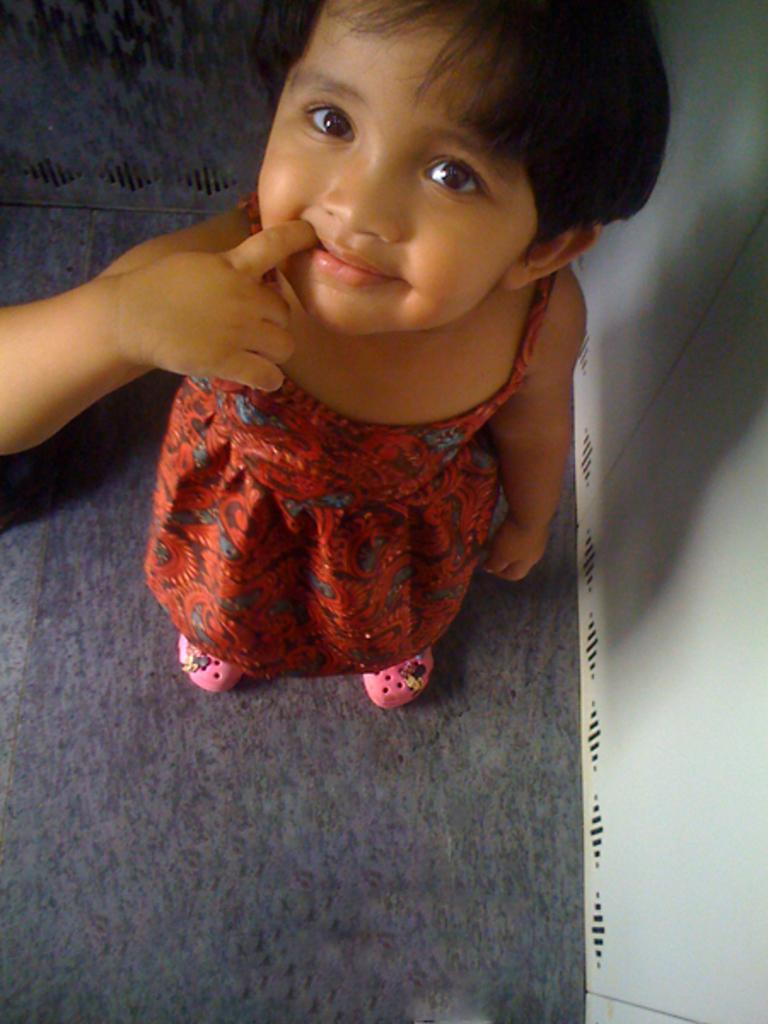In one or two sentences, can you explain what this image depicts? In this image we can see one girl with pink shoes standing near to the white object looks like a wall and carpet on the floor. 